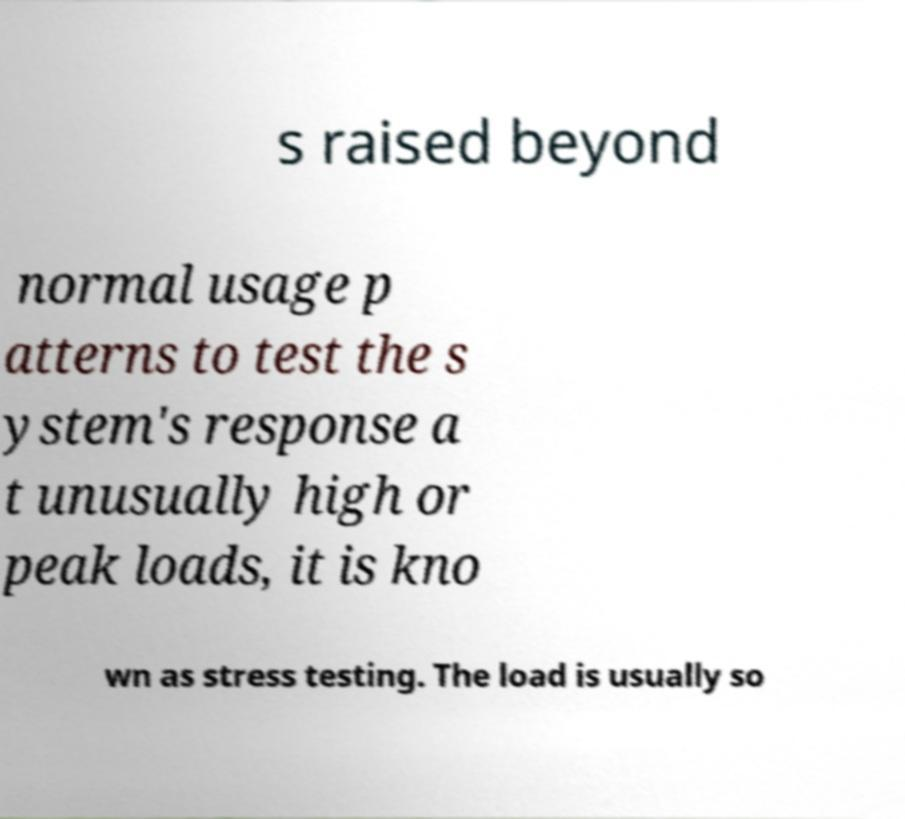Can you read and provide the text displayed in the image?This photo seems to have some interesting text. Can you extract and type it out for me? s raised beyond normal usage p atterns to test the s ystem's response a t unusually high or peak loads, it is kno wn as stress testing. The load is usually so 